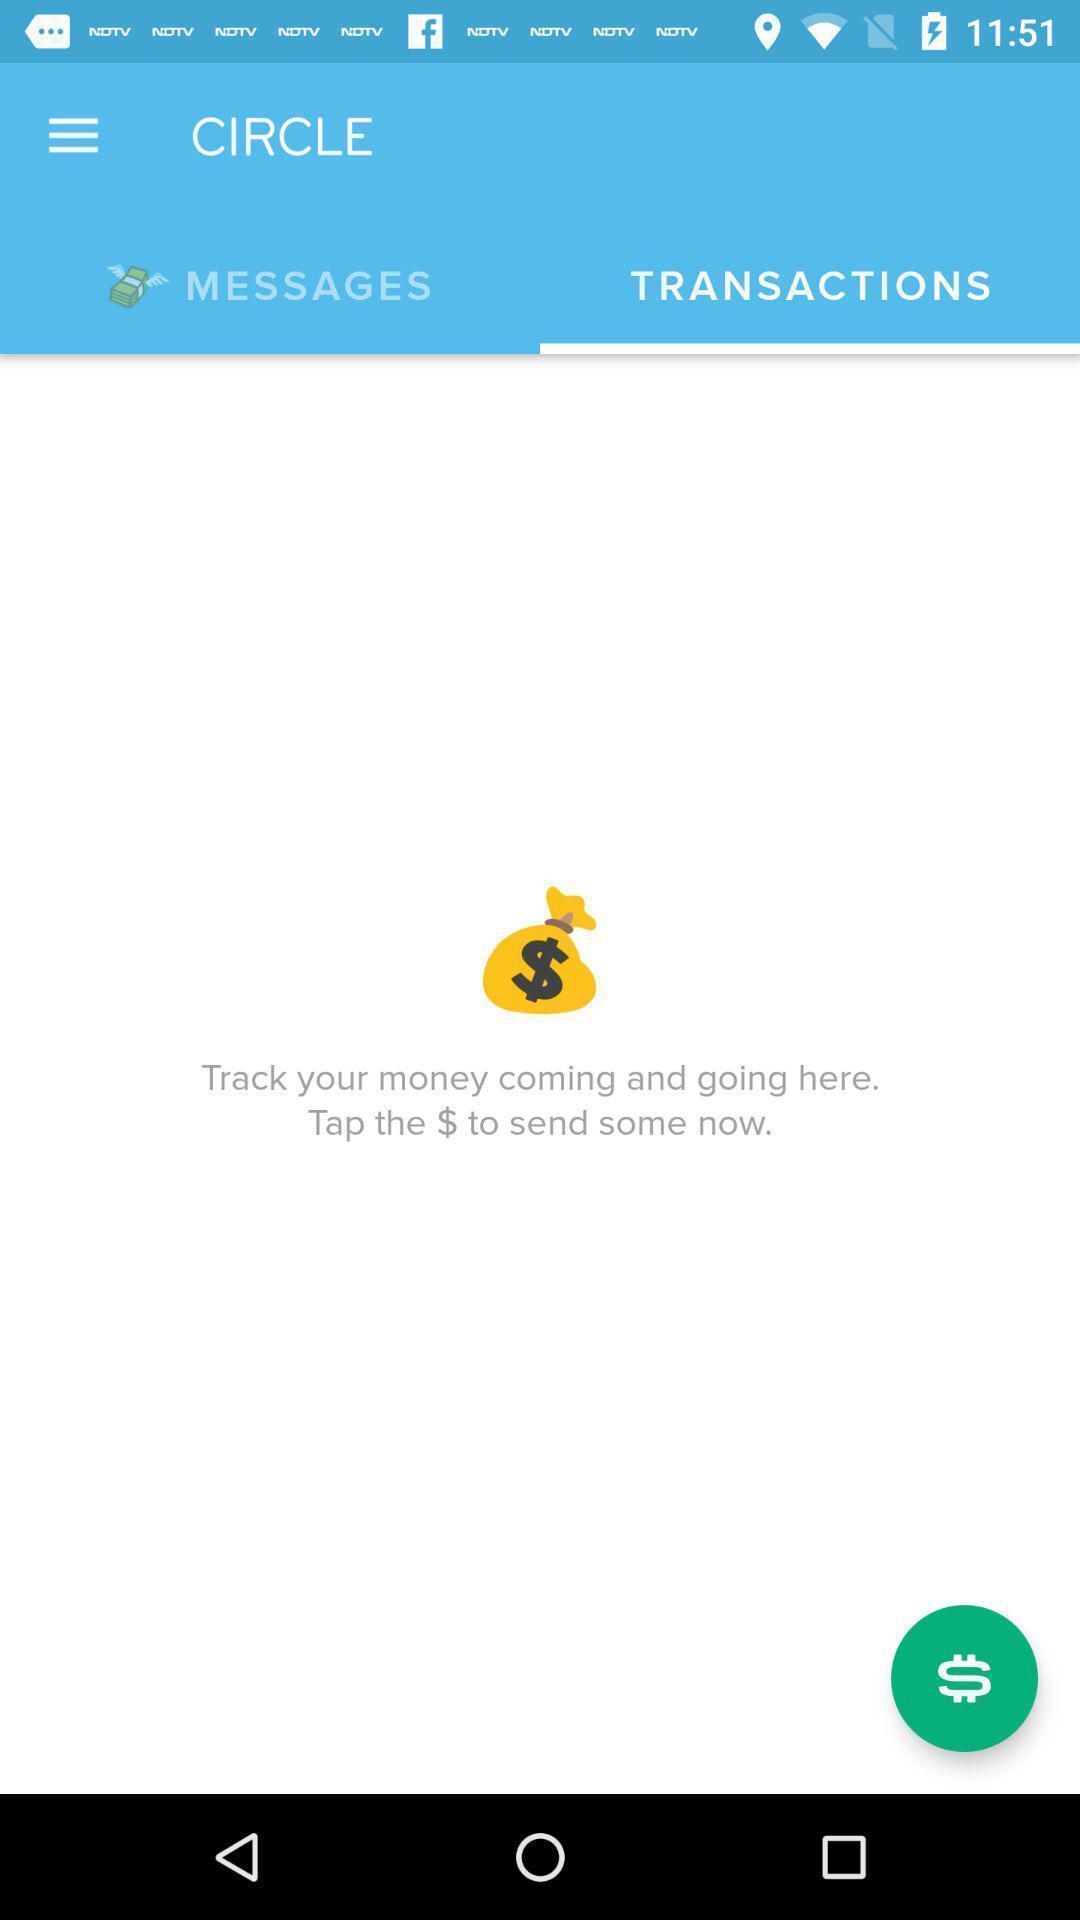What is the overall content of this screenshot? Payment screen. 